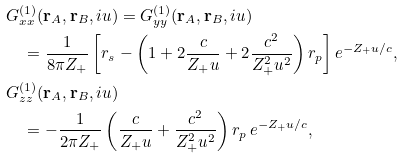<formula> <loc_0><loc_0><loc_500><loc_500>& G ^ { ( 1 ) } _ { x x } ( \mathbf r _ { A } , \mathbf r _ { B } , i u ) = G ^ { ( 1 ) } _ { y y } ( \mathbf r _ { A } , \mathbf r _ { B } , i u ) \\ & \quad = \frac { 1 } { 8 \pi Z _ { + } } \left [ r _ { s } - \left ( 1 + 2 \frac { c } { Z _ { + } u } + 2 \frac { c ^ { 2 } } { Z _ { + } ^ { 2 } u ^ { 2 } } \right ) r _ { p } \right ] e ^ { - Z _ { + } u / c } , \\ & G ^ { ( 1 ) } _ { z z } ( \mathbf r _ { A } , \mathbf r _ { B } , i u ) \\ & \quad = - \frac { 1 } { 2 \pi Z _ { + } } \left ( \frac { c } { Z _ { + } u } + \frac { c ^ { 2 } } { Z _ { + } ^ { 2 } u ^ { 2 } } \right ) r _ { p } \, e ^ { - Z _ { + } u / c } ,</formula> 